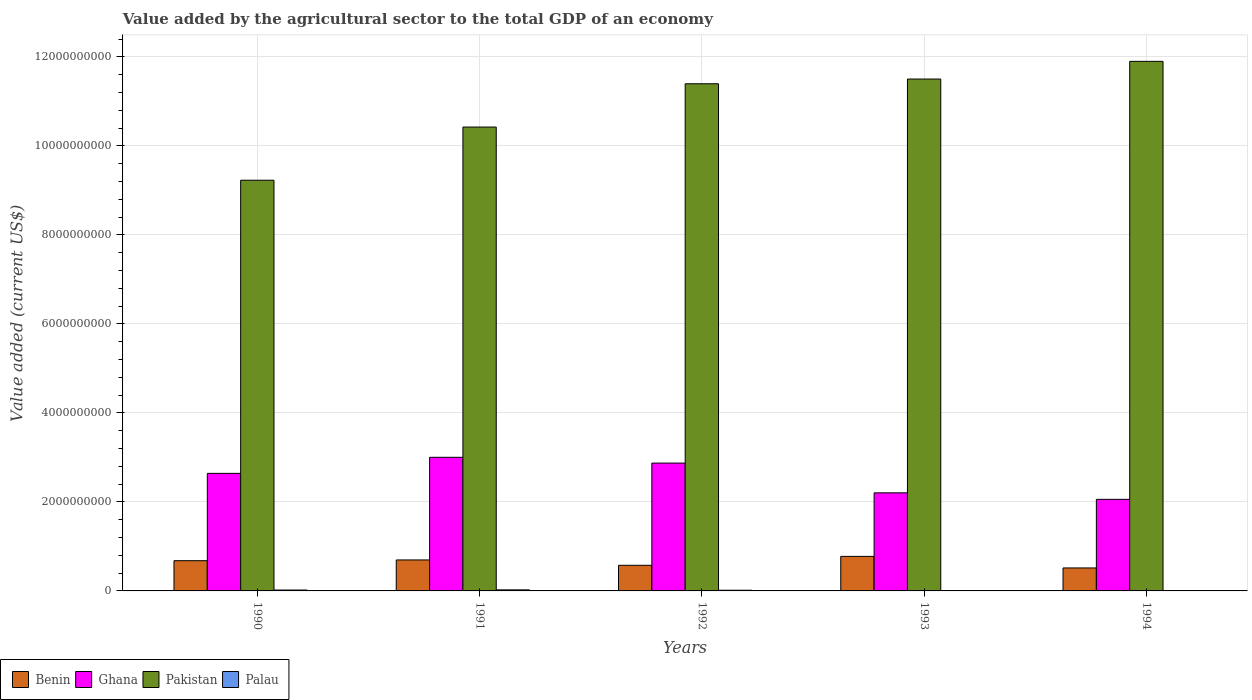How many groups of bars are there?
Your answer should be compact. 5. Are the number of bars on each tick of the X-axis equal?
Ensure brevity in your answer.  Yes. How many bars are there on the 2nd tick from the left?
Ensure brevity in your answer.  4. How many bars are there on the 4th tick from the right?
Ensure brevity in your answer.  4. What is the value added by the agricultural sector to the total GDP in Ghana in 1994?
Provide a succinct answer. 2.06e+09. Across all years, what is the maximum value added by the agricultural sector to the total GDP in Pakistan?
Offer a very short reply. 1.19e+1. Across all years, what is the minimum value added by the agricultural sector to the total GDP in Benin?
Your response must be concise. 5.16e+08. In which year was the value added by the agricultural sector to the total GDP in Ghana maximum?
Give a very brief answer. 1991. What is the total value added by the agricultural sector to the total GDP in Ghana in the graph?
Keep it short and to the point. 1.28e+1. What is the difference between the value added by the agricultural sector to the total GDP in Ghana in 1991 and that in 1993?
Keep it short and to the point. 7.99e+08. What is the difference between the value added by the agricultural sector to the total GDP in Palau in 1993 and the value added by the agricultural sector to the total GDP in Pakistan in 1990?
Give a very brief answer. -9.22e+09. What is the average value added by the agricultural sector to the total GDP in Pakistan per year?
Give a very brief answer. 1.09e+1. In the year 1994, what is the difference between the value added by the agricultural sector to the total GDP in Pakistan and value added by the agricultural sector to the total GDP in Ghana?
Give a very brief answer. 9.84e+09. In how many years, is the value added by the agricultural sector to the total GDP in Benin greater than 3200000000 US$?
Your answer should be very brief. 0. What is the ratio of the value added by the agricultural sector to the total GDP in Benin in 1990 to that in 1992?
Keep it short and to the point. 1.18. What is the difference between the highest and the second highest value added by the agricultural sector to the total GDP in Ghana?
Keep it short and to the point. 1.30e+08. What is the difference between the highest and the lowest value added by the agricultural sector to the total GDP in Benin?
Make the answer very short. 2.60e+08. What does the 1st bar from the left in 1991 represents?
Ensure brevity in your answer.  Benin. What does the 1st bar from the right in 1994 represents?
Offer a terse response. Palau. Are all the bars in the graph horizontal?
Provide a succinct answer. No. Are the values on the major ticks of Y-axis written in scientific E-notation?
Your answer should be compact. No. Does the graph contain any zero values?
Your response must be concise. No. Does the graph contain grids?
Offer a very short reply. Yes. How many legend labels are there?
Offer a very short reply. 4. What is the title of the graph?
Offer a terse response. Value added by the agricultural sector to the total GDP of an economy. What is the label or title of the Y-axis?
Your answer should be very brief. Value added (current US$). What is the Value added (current US$) in Benin in 1990?
Keep it short and to the point. 6.79e+08. What is the Value added (current US$) of Ghana in 1990?
Ensure brevity in your answer.  2.64e+09. What is the Value added (current US$) of Pakistan in 1990?
Make the answer very short. 9.23e+09. What is the Value added (current US$) in Palau in 1990?
Offer a very short reply. 1.99e+07. What is the Value added (current US$) of Benin in 1991?
Give a very brief answer. 6.96e+08. What is the Value added (current US$) in Ghana in 1991?
Give a very brief answer. 3.00e+09. What is the Value added (current US$) in Pakistan in 1991?
Keep it short and to the point. 1.04e+1. What is the Value added (current US$) in Palau in 1991?
Make the answer very short. 2.36e+07. What is the Value added (current US$) of Benin in 1992?
Provide a short and direct response. 5.75e+08. What is the Value added (current US$) of Ghana in 1992?
Your answer should be compact. 2.87e+09. What is the Value added (current US$) in Pakistan in 1992?
Your answer should be very brief. 1.14e+1. What is the Value added (current US$) in Palau in 1992?
Your answer should be compact. 1.53e+07. What is the Value added (current US$) of Benin in 1993?
Your response must be concise. 7.76e+08. What is the Value added (current US$) in Ghana in 1993?
Your answer should be compact. 2.20e+09. What is the Value added (current US$) in Pakistan in 1993?
Ensure brevity in your answer.  1.15e+1. What is the Value added (current US$) of Palau in 1993?
Provide a succinct answer. 8.08e+06. What is the Value added (current US$) in Benin in 1994?
Your response must be concise. 5.16e+08. What is the Value added (current US$) of Ghana in 1994?
Provide a succinct answer. 2.06e+09. What is the Value added (current US$) of Pakistan in 1994?
Make the answer very short. 1.19e+1. What is the Value added (current US$) of Palau in 1994?
Offer a terse response. 6.79e+06. Across all years, what is the maximum Value added (current US$) in Benin?
Give a very brief answer. 7.76e+08. Across all years, what is the maximum Value added (current US$) of Ghana?
Offer a very short reply. 3.00e+09. Across all years, what is the maximum Value added (current US$) of Pakistan?
Make the answer very short. 1.19e+1. Across all years, what is the maximum Value added (current US$) in Palau?
Keep it short and to the point. 2.36e+07. Across all years, what is the minimum Value added (current US$) of Benin?
Make the answer very short. 5.16e+08. Across all years, what is the minimum Value added (current US$) of Ghana?
Make the answer very short. 2.06e+09. Across all years, what is the minimum Value added (current US$) in Pakistan?
Give a very brief answer. 9.23e+09. Across all years, what is the minimum Value added (current US$) in Palau?
Give a very brief answer. 6.79e+06. What is the total Value added (current US$) of Benin in the graph?
Provide a succinct answer. 3.24e+09. What is the total Value added (current US$) of Ghana in the graph?
Offer a terse response. 1.28e+1. What is the total Value added (current US$) in Pakistan in the graph?
Offer a very short reply. 5.44e+1. What is the total Value added (current US$) in Palau in the graph?
Your response must be concise. 7.37e+07. What is the difference between the Value added (current US$) in Benin in 1990 and that in 1991?
Keep it short and to the point. -1.69e+07. What is the difference between the Value added (current US$) of Ghana in 1990 and that in 1991?
Your response must be concise. -3.61e+08. What is the difference between the Value added (current US$) of Pakistan in 1990 and that in 1991?
Your answer should be very brief. -1.19e+09. What is the difference between the Value added (current US$) of Palau in 1990 and that in 1991?
Offer a very short reply. -3.65e+06. What is the difference between the Value added (current US$) in Benin in 1990 and that in 1992?
Keep it short and to the point. 1.04e+08. What is the difference between the Value added (current US$) of Ghana in 1990 and that in 1992?
Give a very brief answer. -2.31e+08. What is the difference between the Value added (current US$) of Pakistan in 1990 and that in 1992?
Your answer should be compact. -2.17e+09. What is the difference between the Value added (current US$) in Palau in 1990 and that in 1992?
Your answer should be very brief. 4.67e+06. What is the difference between the Value added (current US$) of Benin in 1990 and that in 1993?
Make the answer very short. -9.68e+07. What is the difference between the Value added (current US$) in Ghana in 1990 and that in 1993?
Make the answer very short. 4.38e+08. What is the difference between the Value added (current US$) of Pakistan in 1990 and that in 1993?
Provide a succinct answer. -2.27e+09. What is the difference between the Value added (current US$) of Palau in 1990 and that in 1993?
Your answer should be compact. 1.19e+07. What is the difference between the Value added (current US$) of Benin in 1990 and that in 1994?
Your answer should be very brief. 1.63e+08. What is the difference between the Value added (current US$) in Ghana in 1990 and that in 1994?
Make the answer very short. 5.84e+08. What is the difference between the Value added (current US$) of Pakistan in 1990 and that in 1994?
Your response must be concise. -2.67e+09. What is the difference between the Value added (current US$) in Palau in 1990 and that in 1994?
Make the answer very short. 1.32e+07. What is the difference between the Value added (current US$) in Benin in 1991 and that in 1992?
Make the answer very short. 1.21e+08. What is the difference between the Value added (current US$) in Ghana in 1991 and that in 1992?
Offer a very short reply. 1.30e+08. What is the difference between the Value added (current US$) of Pakistan in 1991 and that in 1992?
Ensure brevity in your answer.  -9.73e+08. What is the difference between the Value added (current US$) in Palau in 1991 and that in 1992?
Provide a succinct answer. 8.32e+06. What is the difference between the Value added (current US$) of Benin in 1991 and that in 1993?
Make the answer very short. -7.99e+07. What is the difference between the Value added (current US$) of Ghana in 1991 and that in 1993?
Provide a succinct answer. 7.99e+08. What is the difference between the Value added (current US$) in Pakistan in 1991 and that in 1993?
Ensure brevity in your answer.  -1.08e+09. What is the difference between the Value added (current US$) in Palau in 1991 and that in 1993?
Keep it short and to the point. 1.55e+07. What is the difference between the Value added (current US$) in Benin in 1991 and that in 1994?
Your answer should be very brief. 1.80e+08. What is the difference between the Value added (current US$) of Ghana in 1991 and that in 1994?
Provide a short and direct response. 9.45e+08. What is the difference between the Value added (current US$) in Pakistan in 1991 and that in 1994?
Provide a short and direct response. -1.48e+09. What is the difference between the Value added (current US$) in Palau in 1991 and that in 1994?
Make the answer very short. 1.68e+07. What is the difference between the Value added (current US$) of Benin in 1992 and that in 1993?
Give a very brief answer. -2.01e+08. What is the difference between the Value added (current US$) of Ghana in 1992 and that in 1993?
Your response must be concise. 6.69e+08. What is the difference between the Value added (current US$) in Pakistan in 1992 and that in 1993?
Provide a succinct answer. -1.06e+08. What is the difference between the Value added (current US$) in Palau in 1992 and that in 1993?
Provide a succinct answer. 7.19e+06. What is the difference between the Value added (current US$) in Benin in 1992 and that in 1994?
Your answer should be compact. 5.93e+07. What is the difference between the Value added (current US$) in Ghana in 1992 and that in 1994?
Give a very brief answer. 8.15e+08. What is the difference between the Value added (current US$) of Pakistan in 1992 and that in 1994?
Give a very brief answer. -5.03e+08. What is the difference between the Value added (current US$) in Palau in 1992 and that in 1994?
Provide a succinct answer. 8.48e+06. What is the difference between the Value added (current US$) of Benin in 1993 and that in 1994?
Your answer should be compact. 2.60e+08. What is the difference between the Value added (current US$) in Ghana in 1993 and that in 1994?
Offer a terse response. 1.46e+08. What is the difference between the Value added (current US$) in Pakistan in 1993 and that in 1994?
Provide a short and direct response. -3.97e+08. What is the difference between the Value added (current US$) of Palau in 1993 and that in 1994?
Your answer should be compact. 1.29e+06. What is the difference between the Value added (current US$) of Benin in 1990 and the Value added (current US$) of Ghana in 1991?
Ensure brevity in your answer.  -2.32e+09. What is the difference between the Value added (current US$) of Benin in 1990 and the Value added (current US$) of Pakistan in 1991?
Provide a succinct answer. -9.74e+09. What is the difference between the Value added (current US$) of Benin in 1990 and the Value added (current US$) of Palau in 1991?
Provide a short and direct response. 6.56e+08. What is the difference between the Value added (current US$) in Ghana in 1990 and the Value added (current US$) in Pakistan in 1991?
Your answer should be very brief. -7.78e+09. What is the difference between the Value added (current US$) of Ghana in 1990 and the Value added (current US$) of Palau in 1991?
Your answer should be compact. 2.62e+09. What is the difference between the Value added (current US$) of Pakistan in 1990 and the Value added (current US$) of Palau in 1991?
Ensure brevity in your answer.  9.20e+09. What is the difference between the Value added (current US$) in Benin in 1990 and the Value added (current US$) in Ghana in 1992?
Your response must be concise. -2.19e+09. What is the difference between the Value added (current US$) of Benin in 1990 and the Value added (current US$) of Pakistan in 1992?
Your answer should be very brief. -1.07e+1. What is the difference between the Value added (current US$) in Benin in 1990 and the Value added (current US$) in Palau in 1992?
Provide a short and direct response. 6.64e+08. What is the difference between the Value added (current US$) of Ghana in 1990 and the Value added (current US$) of Pakistan in 1992?
Ensure brevity in your answer.  -8.75e+09. What is the difference between the Value added (current US$) of Ghana in 1990 and the Value added (current US$) of Palau in 1992?
Provide a short and direct response. 2.63e+09. What is the difference between the Value added (current US$) of Pakistan in 1990 and the Value added (current US$) of Palau in 1992?
Offer a terse response. 9.21e+09. What is the difference between the Value added (current US$) of Benin in 1990 and the Value added (current US$) of Ghana in 1993?
Keep it short and to the point. -1.52e+09. What is the difference between the Value added (current US$) in Benin in 1990 and the Value added (current US$) in Pakistan in 1993?
Your response must be concise. -1.08e+1. What is the difference between the Value added (current US$) in Benin in 1990 and the Value added (current US$) in Palau in 1993?
Offer a very short reply. 6.71e+08. What is the difference between the Value added (current US$) in Ghana in 1990 and the Value added (current US$) in Pakistan in 1993?
Make the answer very short. -8.86e+09. What is the difference between the Value added (current US$) in Ghana in 1990 and the Value added (current US$) in Palau in 1993?
Your response must be concise. 2.63e+09. What is the difference between the Value added (current US$) in Pakistan in 1990 and the Value added (current US$) in Palau in 1993?
Offer a terse response. 9.22e+09. What is the difference between the Value added (current US$) in Benin in 1990 and the Value added (current US$) in Ghana in 1994?
Make the answer very short. -1.38e+09. What is the difference between the Value added (current US$) of Benin in 1990 and the Value added (current US$) of Pakistan in 1994?
Offer a terse response. -1.12e+1. What is the difference between the Value added (current US$) of Benin in 1990 and the Value added (current US$) of Palau in 1994?
Your response must be concise. 6.72e+08. What is the difference between the Value added (current US$) of Ghana in 1990 and the Value added (current US$) of Pakistan in 1994?
Ensure brevity in your answer.  -9.26e+09. What is the difference between the Value added (current US$) of Ghana in 1990 and the Value added (current US$) of Palau in 1994?
Your response must be concise. 2.63e+09. What is the difference between the Value added (current US$) of Pakistan in 1990 and the Value added (current US$) of Palau in 1994?
Your answer should be compact. 9.22e+09. What is the difference between the Value added (current US$) of Benin in 1991 and the Value added (current US$) of Ghana in 1992?
Make the answer very short. -2.18e+09. What is the difference between the Value added (current US$) of Benin in 1991 and the Value added (current US$) of Pakistan in 1992?
Make the answer very short. -1.07e+1. What is the difference between the Value added (current US$) in Benin in 1991 and the Value added (current US$) in Palau in 1992?
Your response must be concise. 6.81e+08. What is the difference between the Value added (current US$) in Ghana in 1991 and the Value added (current US$) in Pakistan in 1992?
Keep it short and to the point. -8.39e+09. What is the difference between the Value added (current US$) in Ghana in 1991 and the Value added (current US$) in Palau in 1992?
Ensure brevity in your answer.  2.99e+09. What is the difference between the Value added (current US$) of Pakistan in 1991 and the Value added (current US$) of Palau in 1992?
Provide a short and direct response. 1.04e+1. What is the difference between the Value added (current US$) in Benin in 1991 and the Value added (current US$) in Ghana in 1993?
Your response must be concise. -1.51e+09. What is the difference between the Value added (current US$) in Benin in 1991 and the Value added (current US$) in Pakistan in 1993?
Offer a very short reply. -1.08e+1. What is the difference between the Value added (current US$) of Benin in 1991 and the Value added (current US$) of Palau in 1993?
Provide a succinct answer. 6.88e+08. What is the difference between the Value added (current US$) in Ghana in 1991 and the Value added (current US$) in Pakistan in 1993?
Make the answer very short. -8.50e+09. What is the difference between the Value added (current US$) of Ghana in 1991 and the Value added (current US$) of Palau in 1993?
Provide a succinct answer. 2.99e+09. What is the difference between the Value added (current US$) of Pakistan in 1991 and the Value added (current US$) of Palau in 1993?
Provide a succinct answer. 1.04e+1. What is the difference between the Value added (current US$) in Benin in 1991 and the Value added (current US$) in Ghana in 1994?
Give a very brief answer. -1.36e+09. What is the difference between the Value added (current US$) in Benin in 1991 and the Value added (current US$) in Pakistan in 1994?
Keep it short and to the point. -1.12e+1. What is the difference between the Value added (current US$) in Benin in 1991 and the Value added (current US$) in Palau in 1994?
Offer a terse response. 6.89e+08. What is the difference between the Value added (current US$) of Ghana in 1991 and the Value added (current US$) of Pakistan in 1994?
Keep it short and to the point. -8.90e+09. What is the difference between the Value added (current US$) in Ghana in 1991 and the Value added (current US$) in Palau in 1994?
Provide a succinct answer. 3.00e+09. What is the difference between the Value added (current US$) in Pakistan in 1991 and the Value added (current US$) in Palau in 1994?
Your answer should be compact. 1.04e+1. What is the difference between the Value added (current US$) in Benin in 1992 and the Value added (current US$) in Ghana in 1993?
Ensure brevity in your answer.  -1.63e+09. What is the difference between the Value added (current US$) in Benin in 1992 and the Value added (current US$) in Pakistan in 1993?
Offer a terse response. -1.09e+1. What is the difference between the Value added (current US$) of Benin in 1992 and the Value added (current US$) of Palau in 1993?
Give a very brief answer. 5.67e+08. What is the difference between the Value added (current US$) of Ghana in 1992 and the Value added (current US$) of Pakistan in 1993?
Make the answer very short. -8.63e+09. What is the difference between the Value added (current US$) of Ghana in 1992 and the Value added (current US$) of Palau in 1993?
Provide a short and direct response. 2.86e+09. What is the difference between the Value added (current US$) of Pakistan in 1992 and the Value added (current US$) of Palau in 1993?
Provide a short and direct response. 1.14e+1. What is the difference between the Value added (current US$) of Benin in 1992 and the Value added (current US$) of Ghana in 1994?
Offer a terse response. -1.48e+09. What is the difference between the Value added (current US$) in Benin in 1992 and the Value added (current US$) in Pakistan in 1994?
Keep it short and to the point. -1.13e+1. What is the difference between the Value added (current US$) in Benin in 1992 and the Value added (current US$) in Palau in 1994?
Make the answer very short. 5.69e+08. What is the difference between the Value added (current US$) in Ghana in 1992 and the Value added (current US$) in Pakistan in 1994?
Provide a short and direct response. -9.03e+09. What is the difference between the Value added (current US$) of Ghana in 1992 and the Value added (current US$) of Palau in 1994?
Your answer should be compact. 2.87e+09. What is the difference between the Value added (current US$) in Pakistan in 1992 and the Value added (current US$) in Palau in 1994?
Offer a terse response. 1.14e+1. What is the difference between the Value added (current US$) of Benin in 1993 and the Value added (current US$) of Ghana in 1994?
Provide a succinct answer. -1.28e+09. What is the difference between the Value added (current US$) in Benin in 1993 and the Value added (current US$) in Pakistan in 1994?
Make the answer very short. -1.11e+1. What is the difference between the Value added (current US$) in Benin in 1993 and the Value added (current US$) in Palau in 1994?
Offer a terse response. 7.69e+08. What is the difference between the Value added (current US$) of Ghana in 1993 and the Value added (current US$) of Pakistan in 1994?
Make the answer very short. -9.69e+09. What is the difference between the Value added (current US$) in Ghana in 1993 and the Value added (current US$) in Palau in 1994?
Offer a terse response. 2.20e+09. What is the difference between the Value added (current US$) in Pakistan in 1993 and the Value added (current US$) in Palau in 1994?
Make the answer very short. 1.15e+1. What is the average Value added (current US$) in Benin per year?
Ensure brevity in your answer.  6.49e+08. What is the average Value added (current US$) in Ghana per year?
Your answer should be very brief. 2.56e+09. What is the average Value added (current US$) in Pakistan per year?
Your response must be concise. 1.09e+1. What is the average Value added (current US$) of Palau per year?
Offer a very short reply. 1.47e+07. In the year 1990, what is the difference between the Value added (current US$) of Benin and Value added (current US$) of Ghana?
Your response must be concise. -1.96e+09. In the year 1990, what is the difference between the Value added (current US$) of Benin and Value added (current US$) of Pakistan?
Your response must be concise. -8.55e+09. In the year 1990, what is the difference between the Value added (current US$) of Benin and Value added (current US$) of Palau?
Your answer should be compact. 6.59e+08. In the year 1990, what is the difference between the Value added (current US$) in Ghana and Value added (current US$) in Pakistan?
Offer a very short reply. -6.59e+09. In the year 1990, what is the difference between the Value added (current US$) of Ghana and Value added (current US$) of Palau?
Your answer should be compact. 2.62e+09. In the year 1990, what is the difference between the Value added (current US$) of Pakistan and Value added (current US$) of Palau?
Ensure brevity in your answer.  9.21e+09. In the year 1991, what is the difference between the Value added (current US$) of Benin and Value added (current US$) of Ghana?
Provide a short and direct response. -2.31e+09. In the year 1991, what is the difference between the Value added (current US$) in Benin and Value added (current US$) in Pakistan?
Ensure brevity in your answer.  -9.73e+09. In the year 1991, what is the difference between the Value added (current US$) in Benin and Value added (current US$) in Palau?
Your response must be concise. 6.73e+08. In the year 1991, what is the difference between the Value added (current US$) in Ghana and Value added (current US$) in Pakistan?
Your response must be concise. -7.42e+09. In the year 1991, what is the difference between the Value added (current US$) of Ghana and Value added (current US$) of Palau?
Offer a terse response. 2.98e+09. In the year 1991, what is the difference between the Value added (current US$) in Pakistan and Value added (current US$) in Palau?
Your answer should be very brief. 1.04e+1. In the year 1992, what is the difference between the Value added (current US$) of Benin and Value added (current US$) of Ghana?
Give a very brief answer. -2.30e+09. In the year 1992, what is the difference between the Value added (current US$) in Benin and Value added (current US$) in Pakistan?
Provide a short and direct response. -1.08e+1. In the year 1992, what is the difference between the Value added (current US$) in Benin and Value added (current US$) in Palau?
Ensure brevity in your answer.  5.60e+08. In the year 1992, what is the difference between the Value added (current US$) of Ghana and Value added (current US$) of Pakistan?
Offer a very short reply. -8.52e+09. In the year 1992, what is the difference between the Value added (current US$) of Ghana and Value added (current US$) of Palau?
Your response must be concise. 2.86e+09. In the year 1992, what is the difference between the Value added (current US$) of Pakistan and Value added (current US$) of Palau?
Offer a very short reply. 1.14e+1. In the year 1993, what is the difference between the Value added (current US$) in Benin and Value added (current US$) in Ghana?
Offer a terse response. -1.43e+09. In the year 1993, what is the difference between the Value added (current US$) of Benin and Value added (current US$) of Pakistan?
Provide a short and direct response. -1.07e+1. In the year 1993, what is the difference between the Value added (current US$) of Benin and Value added (current US$) of Palau?
Your answer should be very brief. 7.68e+08. In the year 1993, what is the difference between the Value added (current US$) of Ghana and Value added (current US$) of Pakistan?
Provide a succinct answer. -9.30e+09. In the year 1993, what is the difference between the Value added (current US$) in Ghana and Value added (current US$) in Palau?
Ensure brevity in your answer.  2.20e+09. In the year 1993, what is the difference between the Value added (current US$) in Pakistan and Value added (current US$) in Palau?
Provide a short and direct response. 1.15e+1. In the year 1994, what is the difference between the Value added (current US$) in Benin and Value added (current US$) in Ghana?
Offer a very short reply. -1.54e+09. In the year 1994, what is the difference between the Value added (current US$) in Benin and Value added (current US$) in Pakistan?
Keep it short and to the point. -1.14e+1. In the year 1994, what is the difference between the Value added (current US$) of Benin and Value added (current US$) of Palau?
Your answer should be compact. 5.09e+08. In the year 1994, what is the difference between the Value added (current US$) in Ghana and Value added (current US$) in Pakistan?
Keep it short and to the point. -9.84e+09. In the year 1994, what is the difference between the Value added (current US$) in Ghana and Value added (current US$) in Palau?
Your response must be concise. 2.05e+09. In the year 1994, what is the difference between the Value added (current US$) in Pakistan and Value added (current US$) in Palau?
Keep it short and to the point. 1.19e+1. What is the ratio of the Value added (current US$) in Benin in 1990 to that in 1991?
Offer a terse response. 0.98. What is the ratio of the Value added (current US$) in Ghana in 1990 to that in 1991?
Give a very brief answer. 0.88. What is the ratio of the Value added (current US$) of Pakistan in 1990 to that in 1991?
Provide a short and direct response. 0.89. What is the ratio of the Value added (current US$) of Palau in 1990 to that in 1991?
Your answer should be compact. 0.85. What is the ratio of the Value added (current US$) of Benin in 1990 to that in 1992?
Keep it short and to the point. 1.18. What is the ratio of the Value added (current US$) of Ghana in 1990 to that in 1992?
Ensure brevity in your answer.  0.92. What is the ratio of the Value added (current US$) of Pakistan in 1990 to that in 1992?
Provide a short and direct response. 0.81. What is the ratio of the Value added (current US$) in Palau in 1990 to that in 1992?
Offer a very short reply. 1.31. What is the ratio of the Value added (current US$) in Benin in 1990 to that in 1993?
Make the answer very short. 0.88. What is the ratio of the Value added (current US$) of Ghana in 1990 to that in 1993?
Keep it short and to the point. 1.2. What is the ratio of the Value added (current US$) of Pakistan in 1990 to that in 1993?
Offer a terse response. 0.8. What is the ratio of the Value added (current US$) of Palau in 1990 to that in 1993?
Your answer should be compact. 2.47. What is the ratio of the Value added (current US$) of Benin in 1990 to that in 1994?
Ensure brevity in your answer.  1.32. What is the ratio of the Value added (current US$) of Ghana in 1990 to that in 1994?
Offer a very short reply. 1.28. What is the ratio of the Value added (current US$) in Pakistan in 1990 to that in 1994?
Make the answer very short. 0.78. What is the ratio of the Value added (current US$) in Palau in 1990 to that in 1994?
Keep it short and to the point. 2.94. What is the ratio of the Value added (current US$) of Benin in 1991 to that in 1992?
Provide a succinct answer. 1.21. What is the ratio of the Value added (current US$) in Ghana in 1991 to that in 1992?
Provide a short and direct response. 1.05. What is the ratio of the Value added (current US$) of Pakistan in 1991 to that in 1992?
Provide a short and direct response. 0.91. What is the ratio of the Value added (current US$) in Palau in 1991 to that in 1992?
Your answer should be compact. 1.54. What is the ratio of the Value added (current US$) of Benin in 1991 to that in 1993?
Offer a terse response. 0.9. What is the ratio of the Value added (current US$) of Ghana in 1991 to that in 1993?
Make the answer very short. 1.36. What is the ratio of the Value added (current US$) of Pakistan in 1991 to that in 1993?
Provide a succinct answer. 0.91. What is the ratio of the Value added (current US$) in Palau in 1991 to that in 1993?
Offer a very short reply. 2.92. What is the ratio of the Value added (current US$) of Benin in 1991 to that in 1994?
Your answer should be very brief. 1.35. What is the ratio of the Value added (current US$) of Ghana in 1991 to that in 1994?
Ensure brevity in your answer.  1.46. What is the ratio of the Value added (current US$) in Pakistan in 1991 to that in 1994?
Keep it short and to the point. 0.88. What is the ratio of the Value added (current US$) in Palau in 1991 to that in 1994?
Keep it short and to the point. 3.47. What is the ratio of the Value added (current US$) in Benin in 1992 to that in 1993?
Ensure brevity in your answer.  0.74. What is the ratio of the Value added (current US$) of Ghana in 1992 to that in 1993?
Offer a terse response. 1.3. What is the ratio of the Value added (current US$) in Pakistan in 1992 to that in 1993?
Offer a very short reply. 0.99. What is the ratio of the Value added (current US$) in Palau in 1992 to that in 1993?
Your answer should be compact. 1.89. What is the ratio of the Value added (current US$) in Benin in 1992 to that in 1994?
Keep it short and to the point. 1.11. What is the ratio of the Value added (current US$) in Ghana in 1992 to that in 1994?
Keep it short and to the point. 1.4. What is the ratio of the Value added (current US$) of Pakistan in 1992 to that in 1994?
Your response must be concise. 0.96. What is the ratio of the Value added (current US$) in Palau in 1992 to that in 1994?
Your answer should be very brief. 2.25. What is the ratio of the Value added (current US$) of Benin in 1993 to that in 1994?
Ensure brevity in your answer.  1.5. What is the ratio of the Value added (current US$) in Ghana in 1993 to that in 1994?
Your answer should be very brief. 1.07. What is the ratio of the Value added (current US$) in Pakistan in 1993 to that in 1994?
Make the answer very short. 0.97. What is the ratio of the Value added (current US$) in Palau in 1993 to that in 1994?
Keep it short and to the point. 1.19. What is the difference between the highest and the second highest Value added (current US$) in Benin?
Your response must be concise. 7.99e+07. What is the difference between the highest and the second highest Value added (current US$) in Ghana?
Give a very brief answer. 1.30e+08. What is the difference between the highest and the second highest Value added (current US$) of Pakistan?
Provide a short and direct response. 3.97e+08. What is the difference between the highest and the second highest Value added (current US$) in Palau?
Your answer should be very brief. 3.65e+06. What is the difference between the highest and the lowest Value added (current US$) of Benin?
Give a very brief answer. 2.60e+08. What is the difference between the highest and the lowest Value added (current US$) of Ghana?
Offer a very short reply. 9.45e+08. What is the difference between the highest and the lowest Value added (current US$) in Pakistan?
Your answer should be very brief. 2.67e+09. What is the difference between the highest and the lowest Value added (current US$) in Palau?
Provide a succinct answer. 1.68e+07. 